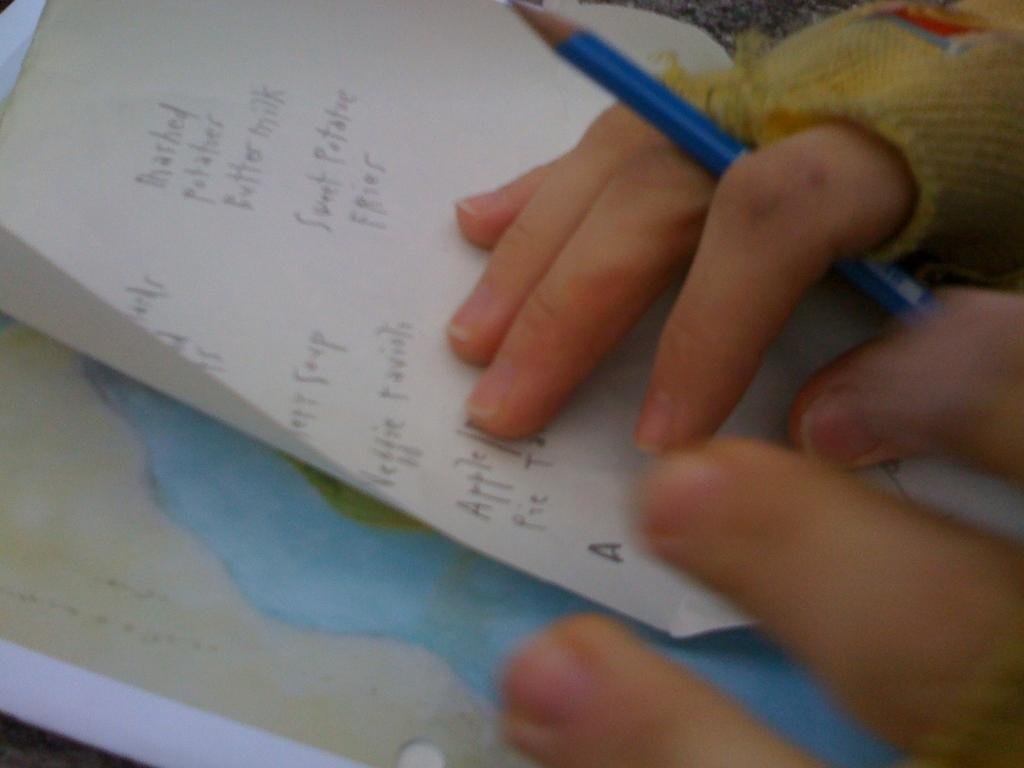What is being held in the person's hand in the image? There is a person's hand holding a pencil in the image. What else can be seen in the image besides the hand and pencil? There are papers in the image. Can you describe the content of the papers? Text is visible on the papers. What type of punishment is being administered to the property in the image? There is no punishment or property present in the image; it only shows a person's hand holding a pencil and papers with text. 